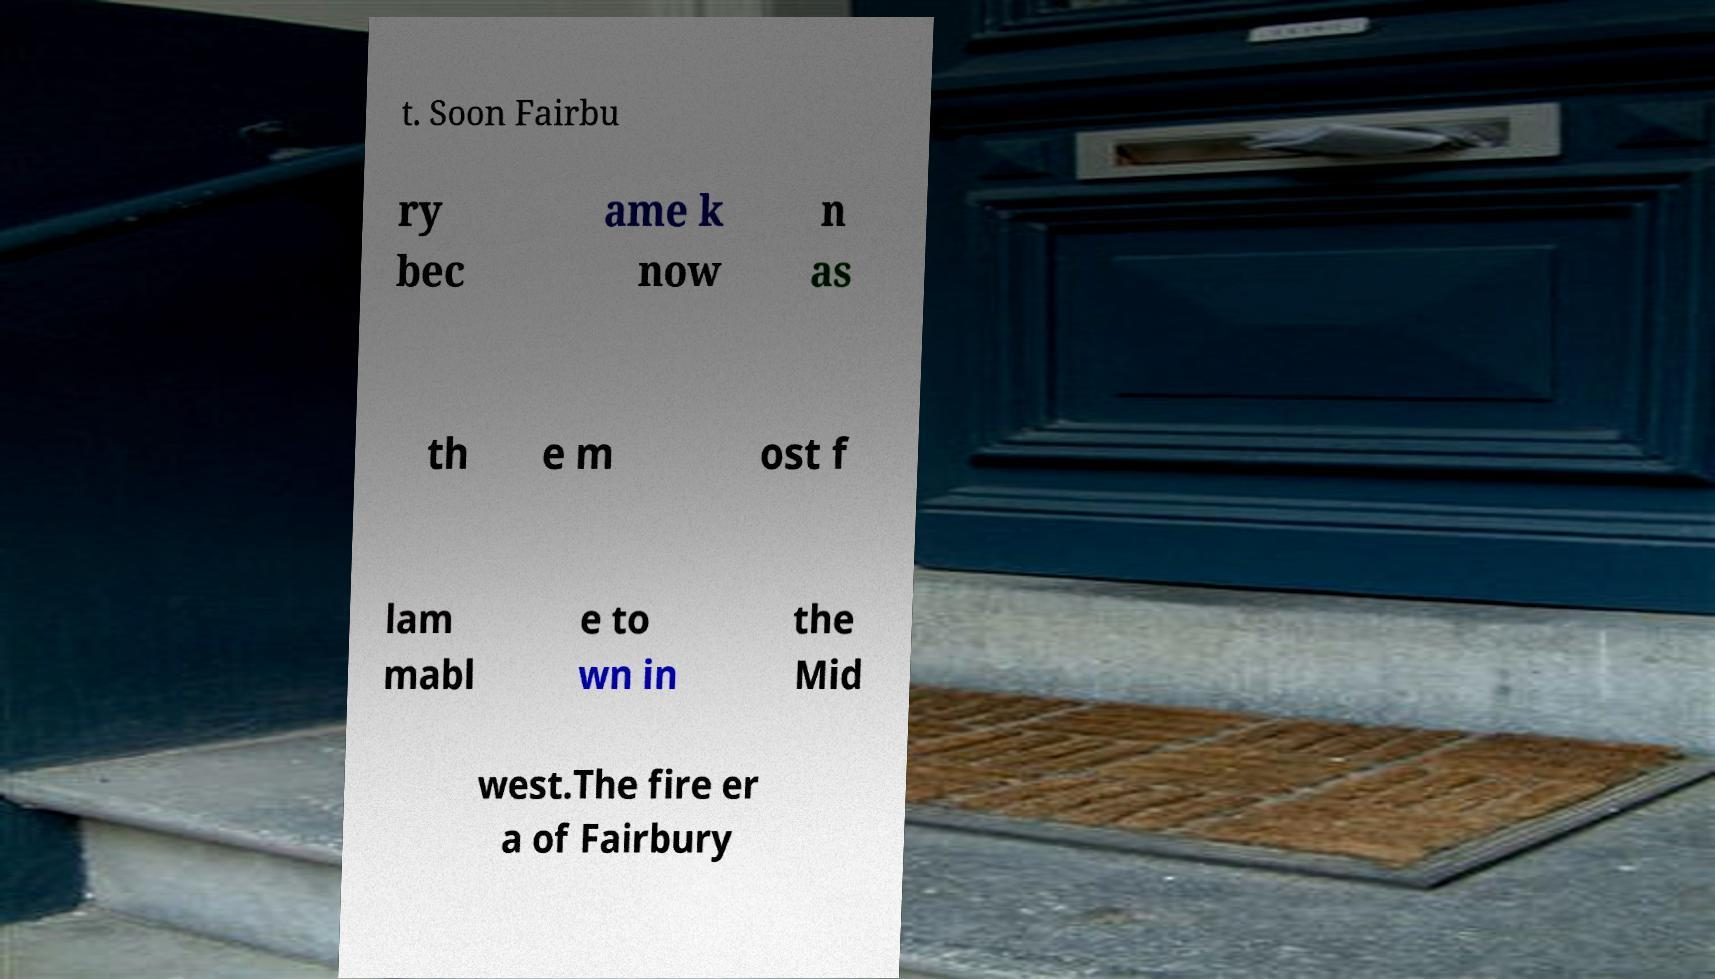For documentation purposes, I need the text within this image transcribed. Could you provide that? t. Soon Fairbu ry bec ame k now n as th e m ost f lam mabl e to wn in the Mid west.The fire er a of Fairbury 